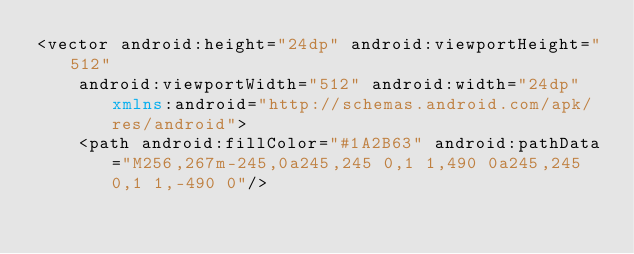<code> <loc_0><loc_0><loc_500><loc_500><_XML_><vector android:height="24dp" android:viewportHeight="512"
    android:viewportWidth="512" android:width="24dp" xmlns:android="http://schemas.android.com/apk/res/android">
    <path android:fillColor="#1A2B63" android:pathData="M256,267m-245,0a245,245 0,1 1,490 0a245,245 0,1 1,-490 0"/></code> 